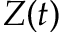<formula> <loc_0><loc_0><loc_500><loc_500>Z ( t )</formula> 